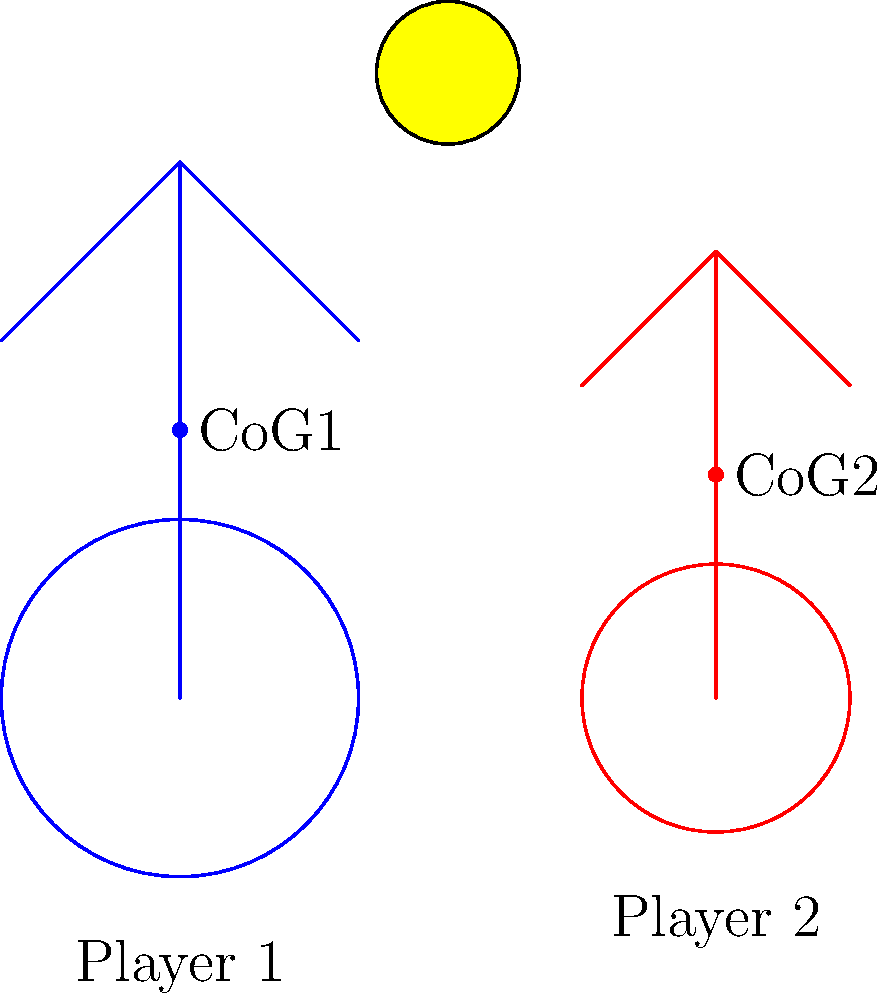In the diagram above, two basketball players with different heights are shown competing for a rebound. Player 1 (blue) is taller than Player 2 (red), and their respective centers of gravity (CoG) are marked. Based on the principles of biomechanics and your knowledge of NBA rebounding statistics, which player is likely to have an advantage in securing the rebound, and why? To answer this question, we need to consider several factors related to rebounding and biomechanics:

1. Center of Gravity (CoG): The taller Player 1 has a higher CoG (CoG1) compared to the shorter Player 2 (CoG2). This affects stability and jumping ability.

2. Reach: Player 1, being taller, has a longer reach, which is crucial for rebounding.

3. Jumping ability: While not shown in the diagram, we can infer that Player 2 might need to jump higher to compensate for the height difference.

4. Stability: A lower CoG generally provides better stability, which could be an advantage for Player 2 in establishing position.

5. NBA statistics: Historically, taller players tend to have higher rebounding averages. For example, players like Mark Eaton and Rudy Gobert of the Utah Jazz have been dominant rebounders due to their height.

6. Leverage: Player 1's higher CoG allows for greater potential energy when jumping, potentially resulting in a higher vertical leap.

7. Timing: While not directly related to height, timing is crucial in rebounding and can offset height advantages.

Considering these factors, Player 1 (taller) is likely to have an advantage in securing the rebound. The primary reasons are:

a) Greater reach due to height
b) Higher center of gravity, allowing for potentially greater jumping height
c) Historical NBA data showing a strong correlation between height and rebounding effectiveness

However, it's important to note that rebounding is not solely determined by height. Factors such as positioning, timing, and technique can allow shorter players to be effective rebounders as well.
Answer: Player 1 (taller) has the advantage due to greater reach and higher center of gravity. 